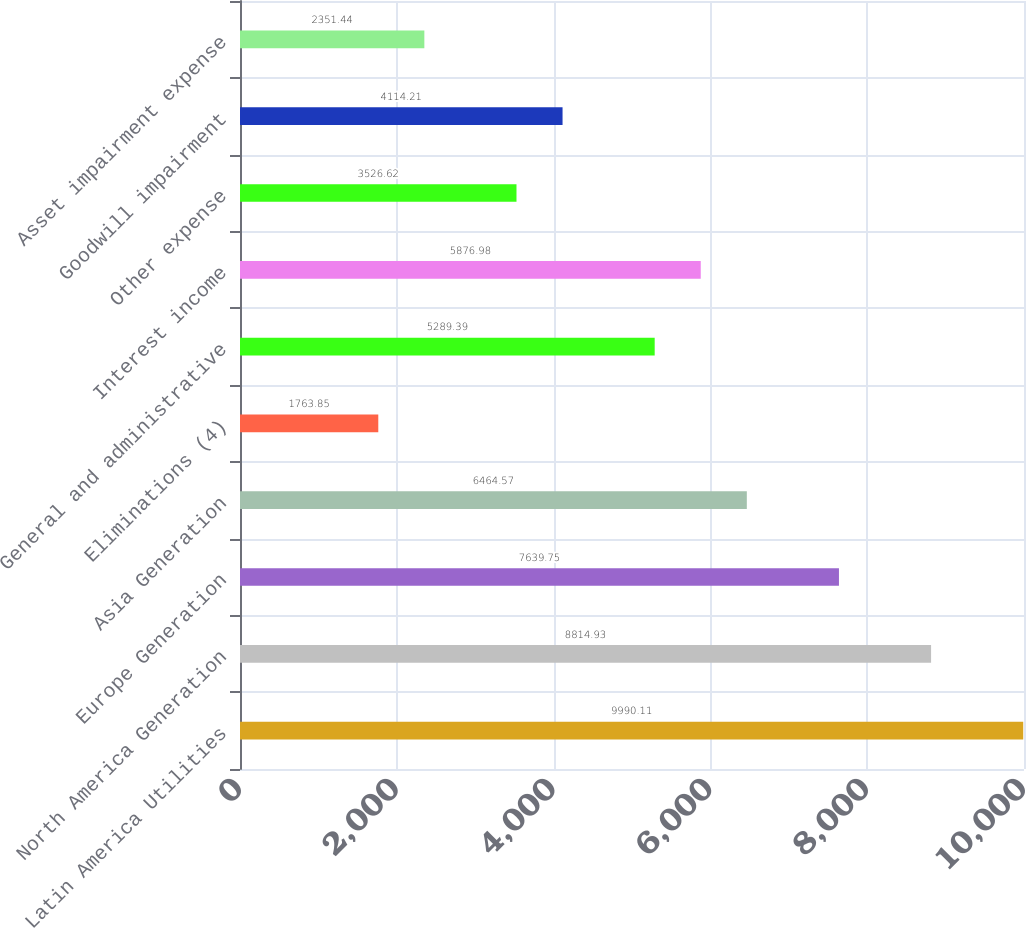Convert chart to OTSL. <chart><loc_0><loc_0><loc_500><loc_500><bar_chart><fcel>Latin America Utilities<fcel>North America Generation<fcel>Europe Generation<fcel>Asia Generation<fcel>Eliminations (4)<fcel>General and administrative<fcel>Interest income<fcel>Other expense<fcel>Goodwill impairment<fcel>Asset impairment expense<nl><fcel>9990.11<fcel>8814.93<fcel>7639.75<fcel>6464.57<fcel>1763.85<fcel>5289.39<fcel>5876.98<fcel>3526.62<fcel>4114.21<fcel>2351.44<nl></chart> 